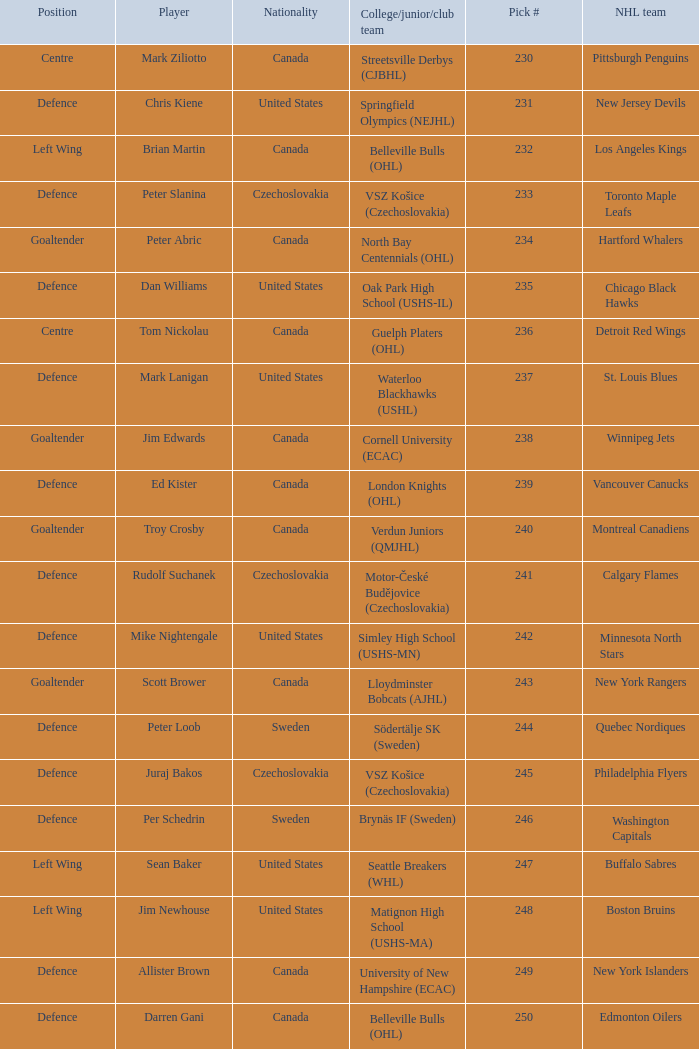What position does allister brown play. Defence. 